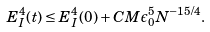<formula> <loc_0><loc_0><loc_500><loc_500>E _ { I } ^ { 4 } ( t ) \leq E _ { I } ^ { 4 } ( 0 ) + C M \epsilon _ { 0 } ^ { 5 } N ^ { - 1 5 / 4 } .</formula> 